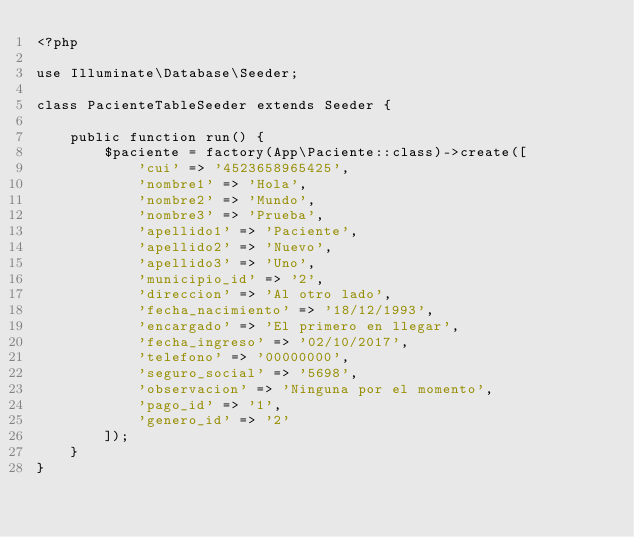<code> <loc_0><loc_0><loc_500><loc_500><_PHP_><?php

use Illuminate\Database\Seeder;

class PacienteTableSeeder extends Seeder {

    public function run() {
        $paciente = factory(App\Paciente::class)->create([
            'cui' => '4523658965425',
            'nombre1' => 'Hola',
            'nombre2' => 'Mundo',
            'nombre3' => 'Prueba',
            'apellido1' => 'Paciente',
            'apellido2' => 'Nuevo',
            'apellido3' => 'Uno',
            'municipio_id' => '2',
            'direccion' => 'Al otro lado',
            'fecha_nacimiento' => '18/12/1993',
            'encargado' => 'El primero en llegar',
            'fecha_ingreso' => '02/10/2017',
            'telefono' => '00000000',
            'seguro_social' => '5698',
            'observacion' => 'Ninguna por el momento',
            'pago_id' => '1',
            'genero_id' => '2'
        ]);
    }
}
</code> 